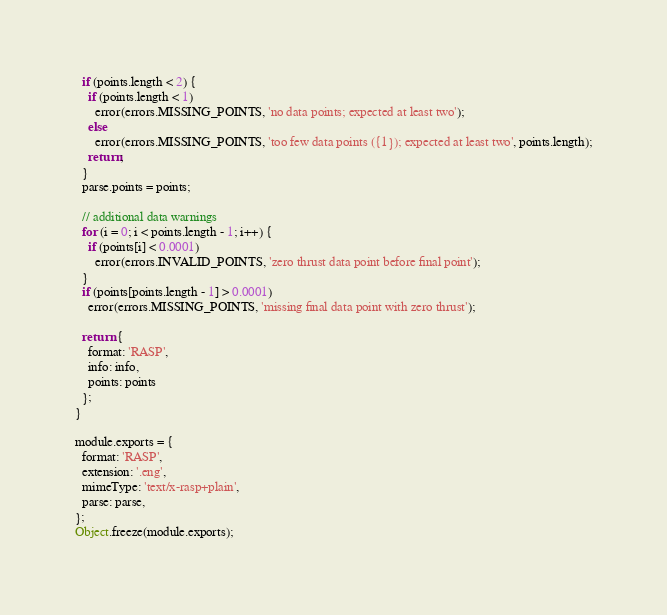<code> <loc_0><loc_0><loc_500><loc_500><_JavaScript_>  if (points.length < 2) {
    if (points.length < 1)
      error(errors.MISSING_POINTS, 'no data points; expected at least two');
    else
      error(errors.MISSING_POINTS, 'too few data points ({1}); expected at least two', points.length);
    return;
  }
  parse.points = points;

  // additional data warnings
  for (i = 0; i < points.length - 1; i++) {
    if (points[i] < 0.0001)
      error(errors.INVALID_POINTS, 'zero thrust data point before final point');
  }
  if (points[points.length - 1] > 0.0001)
    error(errors.MISSING_POINTS, 'missing final data point with zero thrust');

  return {
    format: 'RASP',
    info: info,
    points: points
  };
}

module.exports = {
  format: 'RASP',
  extension: '.eng',
  mimeType: 'text/x-rasp+plain',
  parse: parse,
};
Object.freeze(module.exports);
</code> 